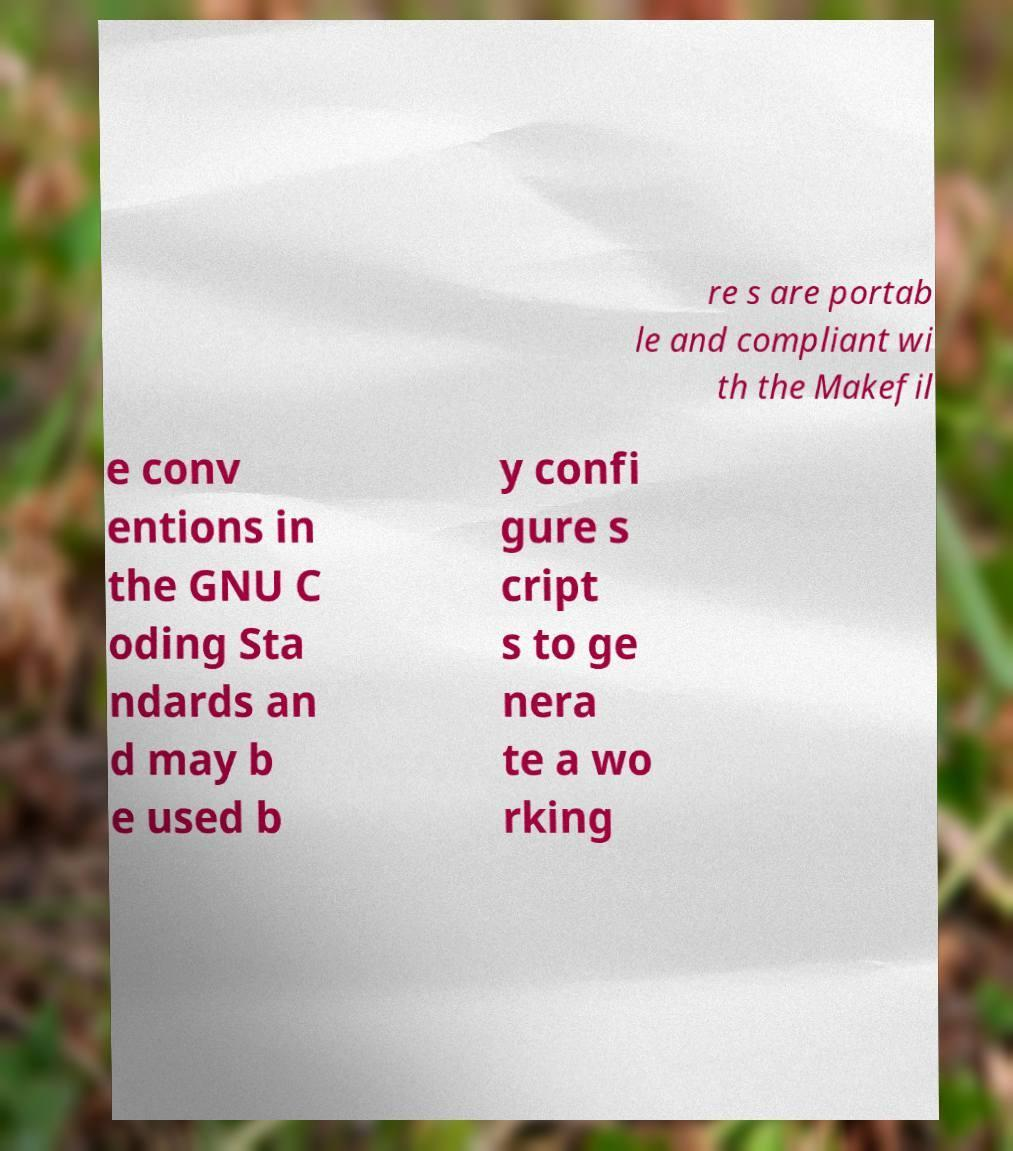Can you accurately transcribe the text from the provided image for me? re s are portab le and compliant wi th the Makefil e conv entions in the GNU C oding Sta ndards an d may b e used b y confi gure s cript s to ge nera te a wo rking 